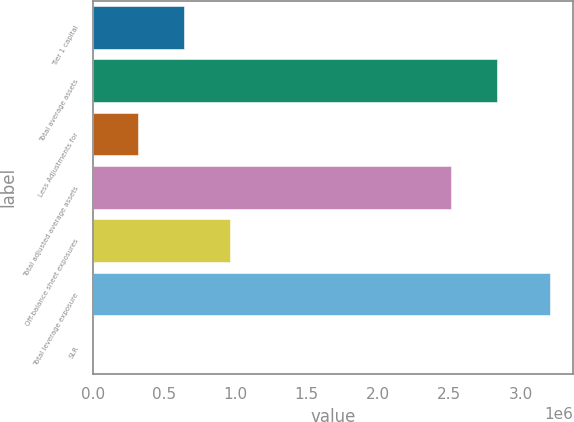<chart> <loc_0><loc_0><loc_500><loc_500><bar_chart><fcel>Tier 1 capital<fcel>Total average assets<fcel>Less Adjustments for<fcel>Total adjusted average assets<fcel>Off-balance sheet exposures<fcel>Total leverage exposure<fcel>SLR<nl><fcel>641008<fcel>2.83532e+06<fcel>320507<fcel>2.51482e+06<fcel>961509<fcel>3.20502e+06<fcel>6.5<nl></chart> 